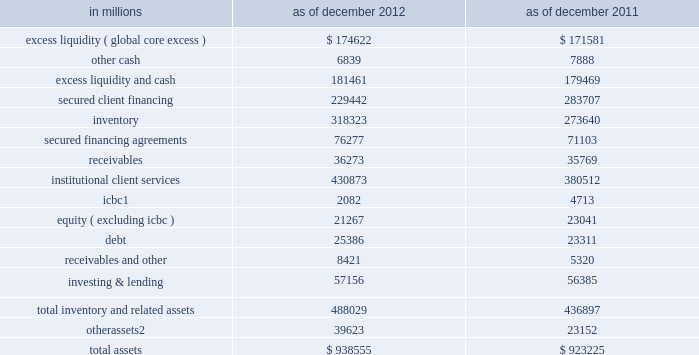Management 2019s discussion and analysis business-specific limits .
The firmwide finance committee sets asset and liability limits for each business and aged inventory limits for certain financial instruments as a disincentive to hold inventory over longer periods of time .
These limits are set at levels which are close to actual operating levels in order to ensure prompt escalation and discussion among business managers and managers in our independent control and support functions on a routine basis .
The firmwide finance committee reviews and approves balance sheet limits on a quarterly basis and may also approve changes in limits on an ad hoc basis in response to changing business needs or market conditions .
Monitoring of key metrics .
We monitor key balance sheet metrics daily both by business and on a consolidated basis , including asset and liability size and composition , aged inventory , limit utilization , risk measures and capital usage .
We allocate assets to businesses and review and analyze movements resulting from new business activity as well as market fluctuations .
Scenario analyses .
We conduct scenario analyses to determine how we would manage the size and composition of our balance sheet and maintain appropriate funding , liquidity and capital positions in a variety of situations : 2030 these scenarios cover short-term and long-term time horizons using various macro-economic and firm-specific assumptions .
We use these analyses to assist us in developing longer-term funding plans , including the level of unsecured debt issuances , the size of our secured funding program and the amount and composition of our equity capital .
We also consider any potential future constraints , such as limits on our ability to grow our asset base in the absence of appropriate funding .
2030 through our internal capital adequacy assessment process ( icaap ) , ccar , the stress tests we are required to conduct under the dodd-frank act , and our resolution and recovery planning , we further analyze how we would manage our balance sheet and risks through the duration of a severe crisis and we develop plans to access funding , generate liquidity , and/or redeploy or issue equity capital , as appropriate .
Balance sheet allocation in addition to preparing our consolidated statements of financial condition in accordance with u.s .
Gaap , we prepare a balance sheet that generally allocates assets to our businesses , which is a non-gaap presentation and may not be comparable to similar non-gaap presentations used by other companies .
We believe that presenting our assets on this basis is meaningful because it is consistent with the way management views and manages risks associated with the firm 2019s assets and better enables investors to assess the liquidity of the firm 2019s assets .
The table below presents a summary of this balance sheet allocation. .
In january 2013 , we sold approximately 45% ( 45 % ) of our ordinary shares of icbc .
Includes assets related to our reinsurance business classified as held for sale as of december 2012 .
See note 12 to the consolidated financial statements for further information .
62 goldman sachs 2012 annual report .
What is the debt-to-asset ratio in 2011? 
Computations: (23311 / 923225)
Answer: 0.02525. 